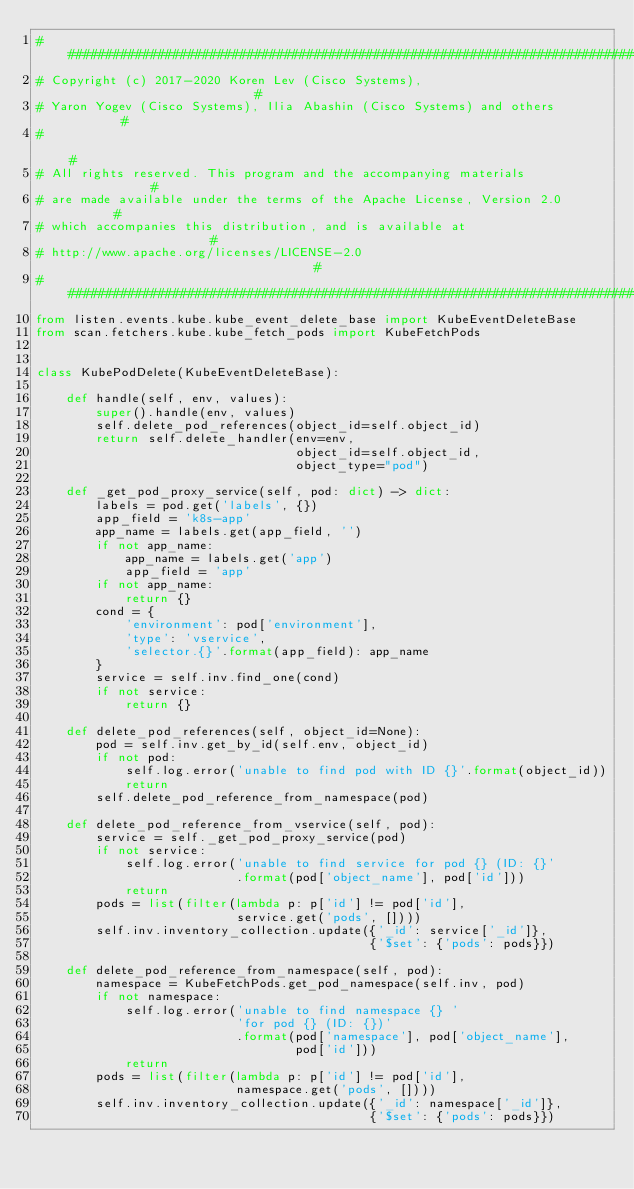Convert code to text. <code><loc_0><loc_0><loc_500><loc_500><_Python_>###############################################################################
# Copyright (c) 2017-2020 Koren Lev (Cisco Systems),                          #
# Yaron Yogev (Cisco Systems), Ilia Abashin (Cisco Systems) and others        #
#                                                                             #
# All rights reserved. This program and the accompanying materials            #
# are made available under the terms of the Apache License, Version 2.0       #
# which accompanies this distribution, and is available at                    #
# http://www.apache.org/licenses/LICENSE-2.0                                  #
###############################################################################
from listen.events.kube.kube_event_delete_base import KubeEventDeleteBase
from scan.fetchers.kube.kube_fetch_pods import KubeFetchPods


class KubePodDelete(KubeEventDeleteBase):

    def handle(self, env, values):
        super().handle(env, values)
        self.delete_pod_references(object_id=self.object_id)
        return self.delete_handler(env=env,
                                   object_id=self.object_id,
                                   object_type="pod")

    def _get_pod_proxy_service(self, pod: dict) -> dict:
        labels = pod.get('labels', {})
        app_field = 'k8s-app'
        app_name = labels.get(app_field, '')
        if not app_name:
            app_name = labels.get('app')
            app_field = 'app'
        if not app_name:
            return {}
        cond = {
            'environment': pod['environment'],
            'type': 'vservice',
            'selector.{}'.format(app_field): app_name
        }
        service = self.inv.find_one(cond)
        if not service:
            return {}

    def delete_pod_references(self, object_id=None):
        pod = self.inv.get_by_id(self.env, object_id)
        if not pod:
            self.log.error('unable to find pod with ID {}'.format(object_id))
            return
        self.delete_pod_reference_from_namespace(pod)

    def delete_pod_reference_from_vservice(self, pod):
        service = self._get_pod_proxy_service(pod)
        if not service:
            self.log.error('unable to find service for pod {} (ID: {}'
                           .format(pod['object_name'], pod['id']))
            return
        pods = list(filter(lambda p: p['id'] != pod['id'],
                           service.get('pods', [])))
        self.inv.inventory_collection.update({'_id': service['_id']},
                                             {'$set': {'pods': pods}})

    def delete_pod_reference_from_namespace(self, pod):
        namespace = KubeFetchPods.get_pod_namespace(self.inv, pod)
        if not namespace:
            self.log.error('unable to find namespace {} '
                           'for pod {} (ID: {})'
                           .format(pod['namespace'], pod['object_name'],
                                   pod['id']))
            return
        pods = list(filter(lambda p: p['id'] != pod['id'],
                           namespace.get('pods', [])))
        self.inv.inventory_collection.update({'_id': namespace['_id']},
                                             {'$set': {'pods': pods}})
</code> 